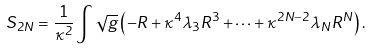<formula> <loc_0><loc_0><loc_500><loc_500>S _ { 2 N } = \frac { 1 } { \kappa ^ { 2 } } \int \sqrt { g } \left ( - R + \kappa ^ { 4 } \lambda _ { 3 } R ^ { 3 } + \cdots + \kappa ^ { 2 N - 2 } \lambda _ { N } R ^ { N } \right ) .</formula> 